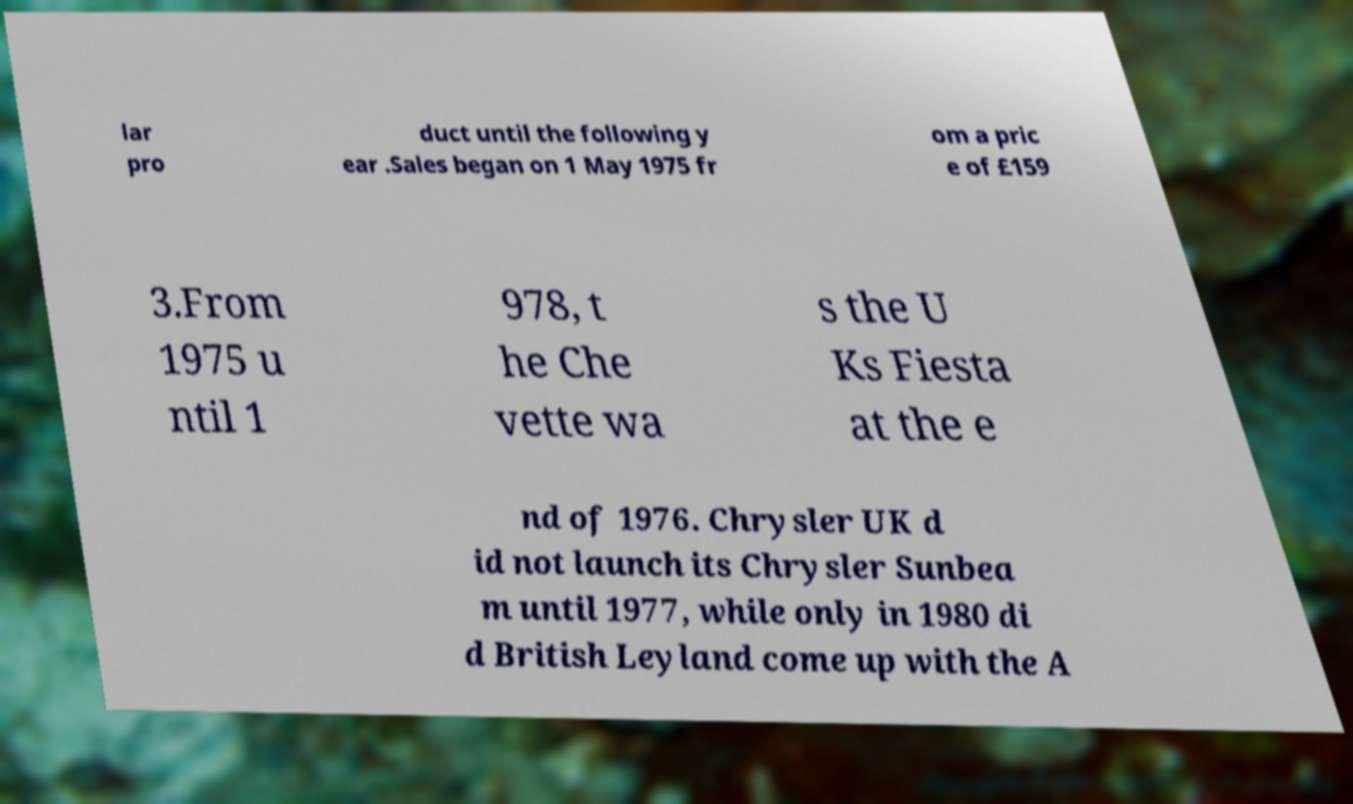For documentation purposes, I need the text within this image transcribed. Could you provide that? lar pro duct until the following y ear .Sales began on 1 May 1975 fr om a pric e of £159 3.From 1975 u ntil 1 978, t he Che vette wa s the U Ks Fiesta at the e nd of 1976. Chrysler UK d id not launch its Chrysler Sunbea m until 1977, while only in 1980 di d British Leyland come up with the A 